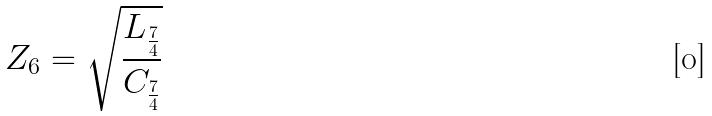<formula> <loc_0><loc_0><loc_500><loc_500>Z _ { 6 } = \sqrt { \frac { L _ { \frac { 7 } { 4 } } } { C _ { \frac { 7 } { 4 } } } }</formula> 